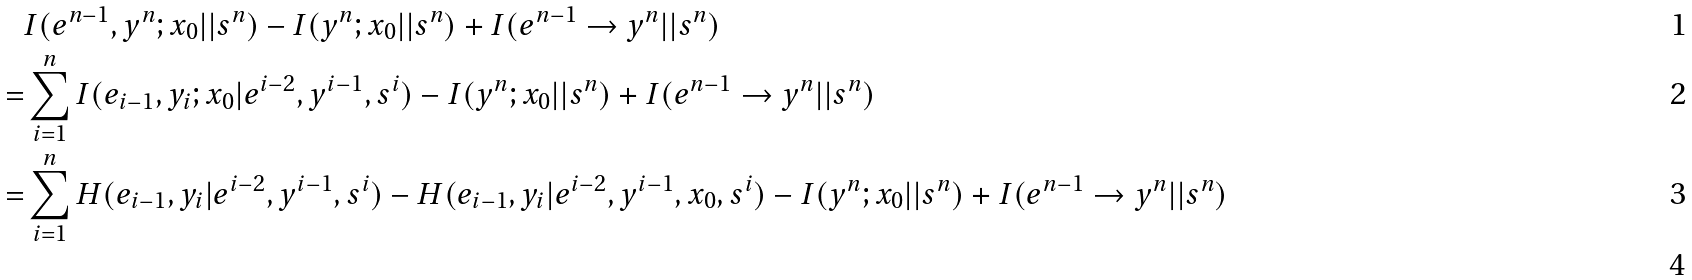<formula> <loc_0><loc_0><loc_500><loc_500>& I ( e ^ { n - 1 } , y ^ { n } ; x _ { 0 } | | s ^ { n } ) - I ( y ^ { n } ; x _ { 0 } | | s ^ { n } ) + I ( e ^ { n - 1 } \rightarrow y ^ { n } | | s ^ { n } ) \\ = & \sum _ { i = 1 } ^ { n } I ( e _ { i - 1 } , y _ { i } ; x _ { 0 } | e ^ { i - 2 } , y ^ { i - 1 } , s ^ { i } ) - I ( y ^ { n } ; x _ { 0 } | | s ^ { n } ) + I ( e ^ { n - 1 } \rightarrow y ^ { n } | | s ^ { n } ) \\ = & \sum _ { i = 1 } ^ { n } H ( e _ { i - 1 } , y _ { i } | e ^ { i - 2 } , y ^ { i - 1 } , s ^ { i } ) - H ( e _ { i - 1 } , y _ { i } | e ^ { i - 2 } , y ^ { i - 1 } , x _ { 0 } , s ^ { i } ) - I ( y ^ { n } ; x _ { 0 } | | s ^ { n } ) + I ( e ^ { n - 1 } \rightarrow y ^ { n } | | s ^ { n } ) \\</formula> 